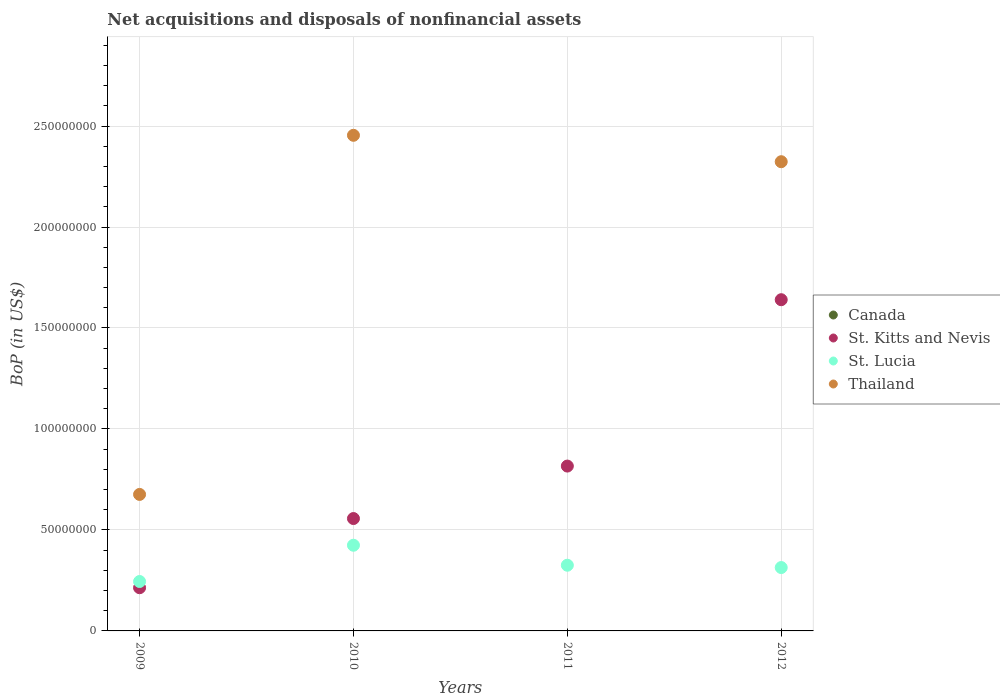Is the number of dotlines equal to the number of legend labels?
Your response must be concise. No. What is the Balance of Payments in St. Lucia in 2012?
Make the answer very short. 3.14e+07. Across all years, what is the maximum Balance of Payments in St. Lucia?
Offer a terse response. 4.24e+07. In which year was the Balance of Payments in St. Kitts and Nevis maximum?
Provide a succinct answer. 2012. What is the total Balance of Payments in St. Kitts and Nevis in the graph?
Your answer should be very brief. 3.23e+08. What is the difference between the Balance of Payments in St. Lucia in 2010 and that in 2012?
Offer a terse response. 1.10e+07. What is the difference between the Balance of Payments in St. Lucia in 2012 and the Balance of Payments in Thailand in 2009?
Provide a short and direct response. -3.62e+07. In the year 2010, what is the difference between the Balance of Payments in St. Lucia and Balance of Payments in St. Kitts and Nevis?
Provide a short and direct response. -1.32e+07. What is the ratio of the Balance of Payments in St. Lucia in 2009 to that in 2012?
Your answer should be very brief. 0.78. Is the difference between the Balance of Payments in St. Lucia in 2009 and 2011 greater than the difference between the Balance of Payments in St. Kitts and Nevis in 2009 and 2011?
Keep it short and to the point. Yes. What is the difference between the highest and the second highest Balance of Payments in Thailand?
Your answer should be compact. 1.31e+07. What is the difference between the highest and the lowest Balance of Payments in St. Lucia?
Offer a very short reply. 1.80e+07. Does the Balance of Payments in St. Kitts and Nevis monotonically increase over the years?
Your answer should be very brief. Yes. Is the Balance of Payments in St. Lucia strictly greater than the Balance of Payments in Canada over the years?
Offer a very short reply. Yes. Is the Balance of Payments in Thailand strictly less than the Balance of Payments in Canada over the years?
Your answer should be very brief. No. What is the difference between two consecutive major ticks on the Y-axis?
Provide a succinct answer. 5.00e+07. Does the graph contain any zero values?
Offer a very short reply. Yes. Does the graph contain grids?
Your answer should be very brief. Yes. Where does the legend appear in the graph?
Give a very brief answer. Center right. How are the legend labels stacked?
Offer a terse response. Vertical. What is the title of the graph?
Your answer should be very brief. Net acquisitions and disposals of nonfinancial assets. Does "Croatia" appear as one of the legend labels in the graph?
Provide a short and direct response. No. What is the label or title of the X-axis?
Provide a succinct answer. Years. What is the label or title of the Y-axis?
Provide a succinct answer. BoP (in US$). What is the BoP (in US$) of St. Kitts and Nevis in 2009?
Your answer should be compact. 2.14e+07. What is the BoP (in US$) of St. Lucia in 2009?
Give a very brief answer. 2.45e+07. What is the BoP (in US$) of Thailand in 2009?
Ensure brevity in your answer.  6.76e+07. What is the BoP (in US$) in St. Kitts and Nevis in 2010?
Offer a terse response. 5.56e+07. What is the BoP (in US$) of St. Lucia in 2010?
Offer a very short reply. 4.24e+07. What is the BoP (in US$) of Thailand in 2010?
Keep it short and to the point. 2.45e+08. What is the BoP (in US$) in Canada in 2011?
Provide a succinct answer. 0. What is the BoP (in US$) of St. Kitts and Nevis in 2011?
Your answer should be compact. 8.16e+07. What is the BoP (in US$) in St. Lucia in 2011?
Ensure brevity in your answer.  3.25e+07. What is the BoP (in US$) in St. Kitts and Nevis in 2012?
Provide a succinct answer. 1.64e+08. What is the BoP (in US$) in St. Lucia in 2012?
Provide a short and direct response. 3.14e+07. What is the BoP (in US$) in Thailand in 2012?
Provide a short and direct response. 2.32e+08. Across all years, what is the maximum BoP (in US$) of St. Kitts and Nevis?
Offer a terse response. 1.64e+08. Across all years, what is the maximum BoP (in US$) in St. Lucia?
Your response must be concise. 4.24e+07. Across all years, what is the maximum BoP (in US$) in Thailand?
Your response must be concise. 2.45e+08. Across all years, what is the minimum BoP (in US$) in St. Kitts and Nevis?
Keep it short and to the point. 2.14e+07. Across all years, what is the minimum BoP (in US$) of St. Lucia?
Provide a short and direct response. 2.45e+07. Across all years, what is the minimum BoP (in US$) in Thailand?
Give a very brief answer. 0. What is the total BoP (in US$) in Canada in the graph?
Provide a succinct answer. 0. What is the total BoP (in US$) of St. Kitts and Nevis in the graph?
Provide a short and direct response. 3.23e+08. What is the total BoP (in US$) in St. Lucia in the graph?
Provide a short and direct response. 1.31e+08. What is the total BoP (in US$) of Thailand in the graph?
Give a very brief answer. 5.45e+08. What is the difference between the BoP (in US$) in St. Kitts and Nevis in 2009 and that in 2010?
Your answer should be compact. -3.43e+07. What is the difference between the BoP (in US$) of St. Lucia in 2009 and that in 2010?
Your answer should be very brief. -1.80e+07. What is the difference between the BoP (in US$) of Thailand in 2009 and that in 2010?
Provide a short and direct response. -1.78e+08. What is the difference between the BoP (in US$) of St. Kitts and Nevis in 2009 and that in 2011?
Your answer should be compact. -6.02e+07. What is the difference between the BoP (in US$) in St. Lucia in 2009 and that in 2011?
Ensure brevity in your answer.  -8.06e+06. What is the difference between the BoP (in US$) of St. Kitts and Nevis in 2009 and that in 2012?
Ensure brevity in your answer.  -1.43e+08. What is the difference between the BoP (in US$) of St. Lucia in 2009 and that in 2012?
Make the answer very short. -6.91e+06. What is the difference between the BoP (in US$) of Thailand in 2009 and that in 2012?
Provide a short and direct response. -1.65e+08. What is the difference between the BoP (in US$) of St. Kitts and Nevis in 2010 and that in 2011?
Offer a very short reply. -2.60e+07. What is the difference between the BoP (in US$) in St. Lucia in 2010 and that in 2011?
Offer a very short reply. 9.90e+06. What is the difference between the BoP (in US$) of St. Kitts and Nevis in 2010 and that in 2012?
Ensure brevity in your answer.  -1.08e+08. What is the difference between the BoP (in US$) in St. Lucia in 2010 and that in 2012?
Provide a short and direct response. 1.10e+07. What is the difference between the BoP (in US$) in Thailand in 2010 and that in 2012?
Your answer should be compact. 1.31e+07. What is the difference between the BoP (in US$) in St. Kitts and Nevis in 2011 and that in 2012?
Make the answer very short. -8.24e+07. What is the difference between the BoP (in US$) of St. Lucia in 2011 and that in 2012?
Your answer should be compact. 1.15e+06. What is the difference between the BoP (in US$) of St. Kitts and Nevis in 2009 and the BoP (in US$) of St. Lucia in 2010?
Your answer should be compact. -2.10e+07. What is the difference between the BoP (in US$) of St. Kitts and Nevis in 2009 and the BoP (in US$) of Thailand in 2010?
Your answer should be very brief. -2.24e+08. What is the difference between the BoP (in US$) of St. Lucia in 2009 and the BoP (in US$) of Thailand in 2010?
Make the answer very short. -2.21e+08. What is the difference between the BoP (in US$) of St. Kitts and Nevis in 2009 and the BoP (in US$) of St. Lucia in 2011?
Offer a terse response. -1.11e+07. What is the difference between the BoP (in US$) in St. Kitts and Nevis in 2009 and the BoP (in US$) in St. Lucia in 2012?
Make the answer very short. -9.99e+06. What is the difference between the BoP (in US$) in St. Kitts and Nevis in 2009 and the BoP (in US$) in Thailand in 2012?
Ensure brevity in your answer.  -2.11e+08. What is the difference between the BoP (in US$) of St. Lucia in 2009 and the BoP (in US$) of Thailand in 2012?
Give a very brief answer. -2.08e+08. What is the difference between the BoP (in US$) in St. Kitts and Nevis in 2010 and the BoP (in US$) in St. Lucia in 2011?
Ensure brevity in your answer.  2.31e+07. What is the difference between the BoP (in US$) of St. Kitts and Nevis in 2010 and the BoP (in US$) of St. Lucia in 2012?
Offer a terse response. 2.43e+07. What is the difference between the BoP (in US$) in St. Kitts and Nevis in 2010 and the BoP (in US$) in Thailand in 2012?
Keep it short and to the point. -1.77e+08. What is the difference between the BoP (in US$) of St. Lucia in 2010 and the BoP (in US$) of Thailand in 2012?
Ensure brevity in your answer.  -1.90e+08. What is the difference between the BoP (in US$) in St. Kitts and Nevis in 2011 and the BoP (in US$) in St. Lucia in 2012?
Make the answer very short. 5.02e+07. What is the difference between the BoP (in US$) in St. Kitts and Nevis in 2011 and the BoP (in US$) in Thailand in 2012?
Offer a very short reply. -1.51e+08. What is the difference between the BoP (in US$) of St. Lucia in 2011 and the BoP (in US$) of Thailand in 2012?
Provide a short and direct response. -2.00e+08. What is the average BoP (in US$) in St. Kitts and Nevis per year?
Ensure brevity in your answer.  8.07e+07. What is the average BoP (in US$) of St. Lucia per year?
Make the answer very short. 3.27e+07. What is the average BoP (in US$) in Thailand per year?
Your response must be concise. 1.36e+08. In the year 2009, what is the difference between the BoP (in US$) in St. Kitts and Nevis and BoP (in US$) in St. Lucia?
Your response must be concise. -3.08e+06. In the year 2009, what is the difference between the BoP (in US$) of St. Kitts and Nevis and BoP (in US$) of Thailand?
Provide a short and direct response. -4.62e+07. In the year 2009, what is the difference between the BoP (in US$) in St. Lucia and BoP (in US$) in Thailand?
Your answer should be compact. -4.31e+07. In the year 2010, what is the difference between the BoP (in US$) in St. Kitts and Nevis and BoP (in US$) in St. Lucia?
Your answer should be compact. 1.32e+07. In the year 2010, what is the difference between the BoP (in US$) of St. Kitts and Nevis and BoP (in US$) of Thailand?
Give a very brief answer. -1.90e+08. In the year 2010, what is the difference between the BoP (in US$) in St. Lucia and BoP (in US$) in Thailand?
Offer a very short reply. -2.03e+08. In the year 2011, what is the difference between the BoP (in US$) of St. Kitts and Nevis and BoP (in US$) of St. Lucia?
Offer a very short reply. 4.91e+07. In the year 2012, what is the difference between the BoP (in US$) of St. Kitts and Nevis and BoP (in US$) of St. Lucia?
Give a very brief answer. 1.33e+08. In the year 2012, what is the difference between the BoP (in US$) of St. Kitts and Nevis and BoP (in US$) of Thailand?
Give a very brief answer. -6.83e+07. In the year 2012, what is the difference between the BoP (in US$) in St. Lucia and BoP (in US$) in Thailand?
Provide a short and direct response. -2.01e+08. What is the ratio of the BoP (in US$) of St. Kitts and Nevis in 2009 to that in 2010?
Ensure brevity in your answer.  0.38. What is the ratio of the BoP (in US$) of St. Lucia in 2009 to that in 2010?
Your response must be concise. 0.58. What is the ratio of the BoP (in US$) in Thailand in 2009 to that in 2010?
Offer a terse response. 0.28. What is the ratio of the BoP (in US$) of St. Kitts and Nevis in 2009 to that in 2011?
Offer a very short reply. 0.26. What is the ratio of the BoP (in US$) of St. Lucia in 2009 to that in 2011?
Give a very brief answer. 0.75. What is the ratio of the BoP (in US$) in St. Kitts and Nevis in 2009 to that in 2012?
Provide a succinct answer. 0.13. What is the ratio of the BoP (in US$) in St. Lucia in 2009 to that in 2012?
Your response must be concise. 0.78. What is the ratio of the BoP (in US$) in Thailand in 2009 to that in 2012?
Your response must be concise. 0.29. What is the ratio of the BoP (in US$) in St. Kitts and Nevis in 2010 to that in 2011?
Give a very brief answer. 0.68. What is the ratio of the BoP (in US$) of St. Lucia in 2010 to that in 2011?
Your response must be concise. 1.3. What is the ratio of the BoP (in US$) in St. Kitts and Nevis in 2010 to that in 2012?
Ensure brevity in your answer.  0.34. What is the ratio of the BoP (in US$) of St. Lucia in 2010 to that in 2012?
Provide a short and direct response. 1.35. What is the ratio of the BoP (in US$) of Thailand in 2010 to that in 2012?
Keep it short and to the point. 1.06. What is the ratio of the BoP (in US$) of St. Kitts and Nevis in 2011 to that in 2012?
Make the answer very short. 0.5. What is the ratio of the BoP (in US$) of St. Lucia in 2011 to that in 2012?
Your answer should be compact. 1.04. What is the difference between the highest and the second highest BoP (in US$) of St. Kitts and Nevis?
Your response must be concise. 8.24e+07. What is the difference between the highest and the second highest BoP (in US$) of St. Lucia?
Your response must be concise. 9.90e+06. What is the difference between the highest and the second highest BoP (in US$) in Thailand?
Offer a terse response. 1.31e+07. What is the difference between the highest and the lowest BoP (in US$) of St. Kitts and Nevis?
Offer a terse response. 1.43e+08. What is the difference between the highest and the lowest BoP (in US$) in St. Lucia?
Provide a succinct answer. 1.80e+07. What is the difference between the highest and the lowest BoP (in US$) in Thailand?
Offer a very short reply. 2.45e+08. 